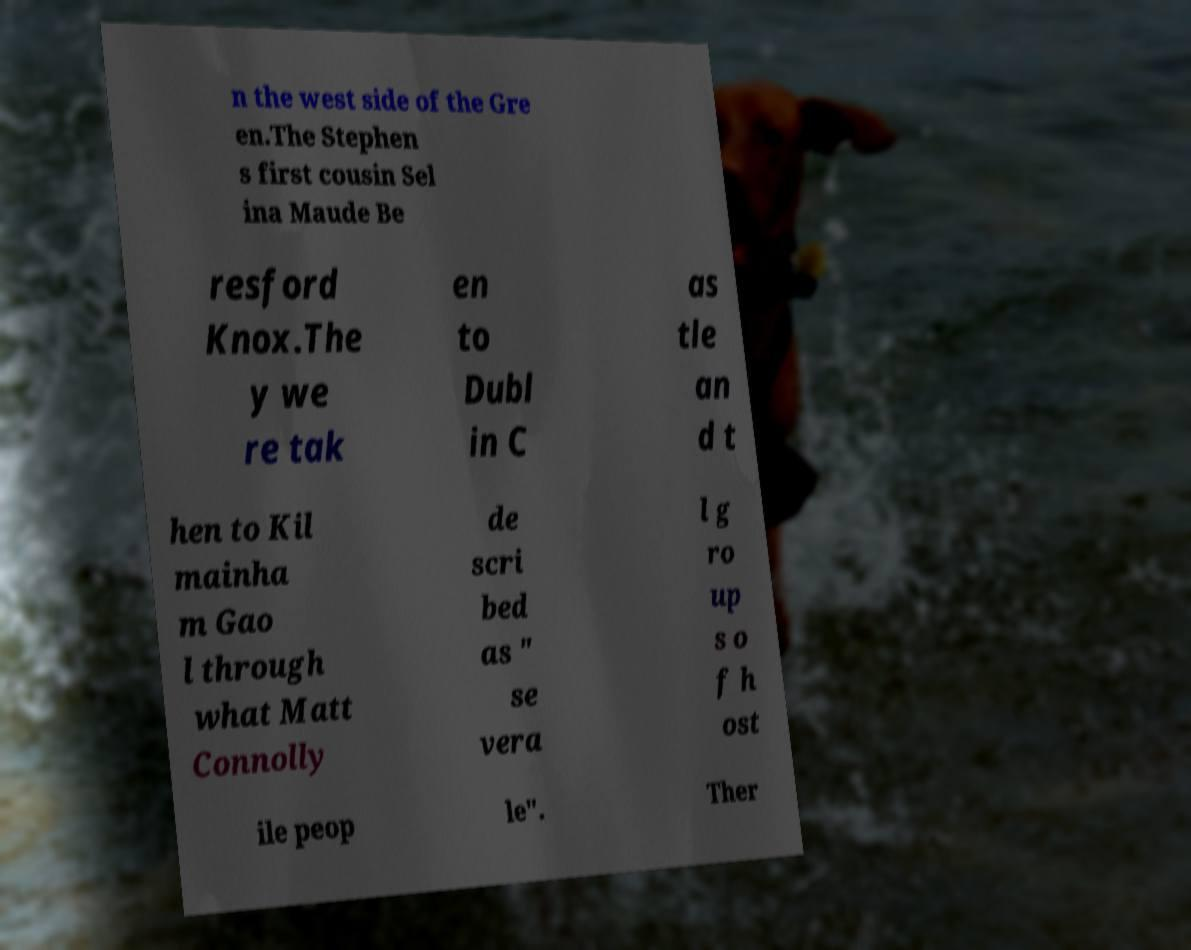Can you read and provide the text displayed in the image?This photo seems to have some interesting text. Can you extract and type it out for me? n the west side of the Gre en.The Stephen s first cousin Sel ina Maude Be resford Knox.The y we re tak en to Dubl in C as tle an d t hen to Kil mainha m Gao l through what Matt Connolly de scri bed as " se vera l g ro up s o f h ost ile peop le". Ther 